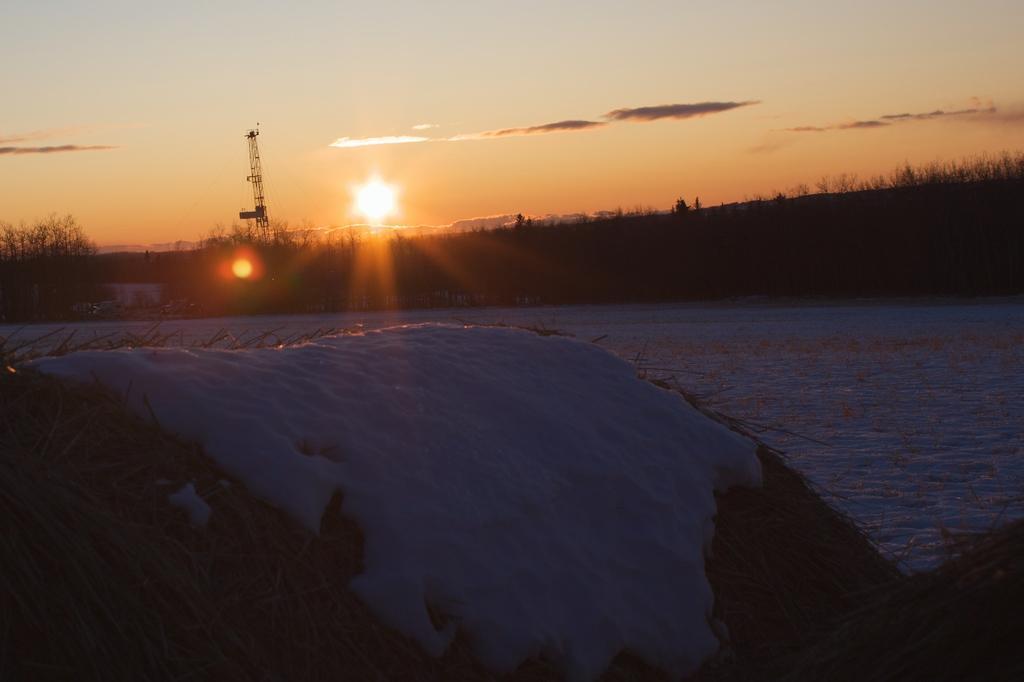How would you summarize this image in a sentence or two? In this image I can see a dry grass and snow. Back Side I can see tower,water,sun and trees. The sky is in white and orange color. 